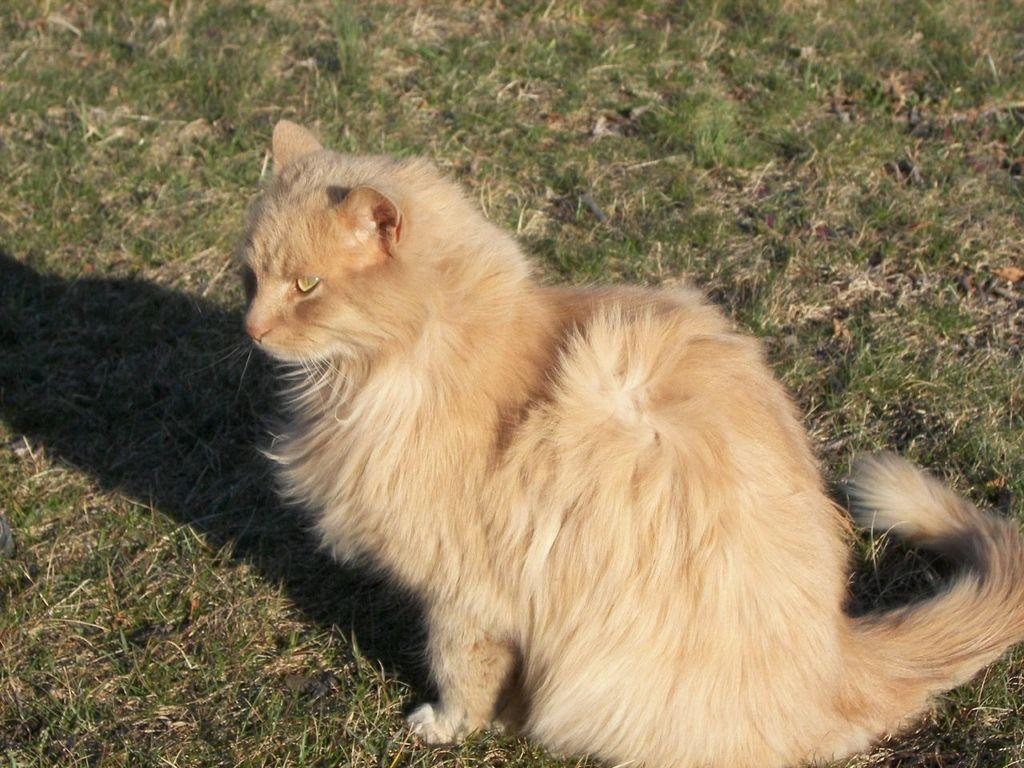What animal is in the foreground of the image? There is a cat in the foreground of the image. What is the cat sitting on? The cat is sitting on the grass. What type of friction can be observed between the cat and the grass in the image? There is no mention of friction in the image, and it is not possible to observe friction between the cat and the grass from the image alone. 